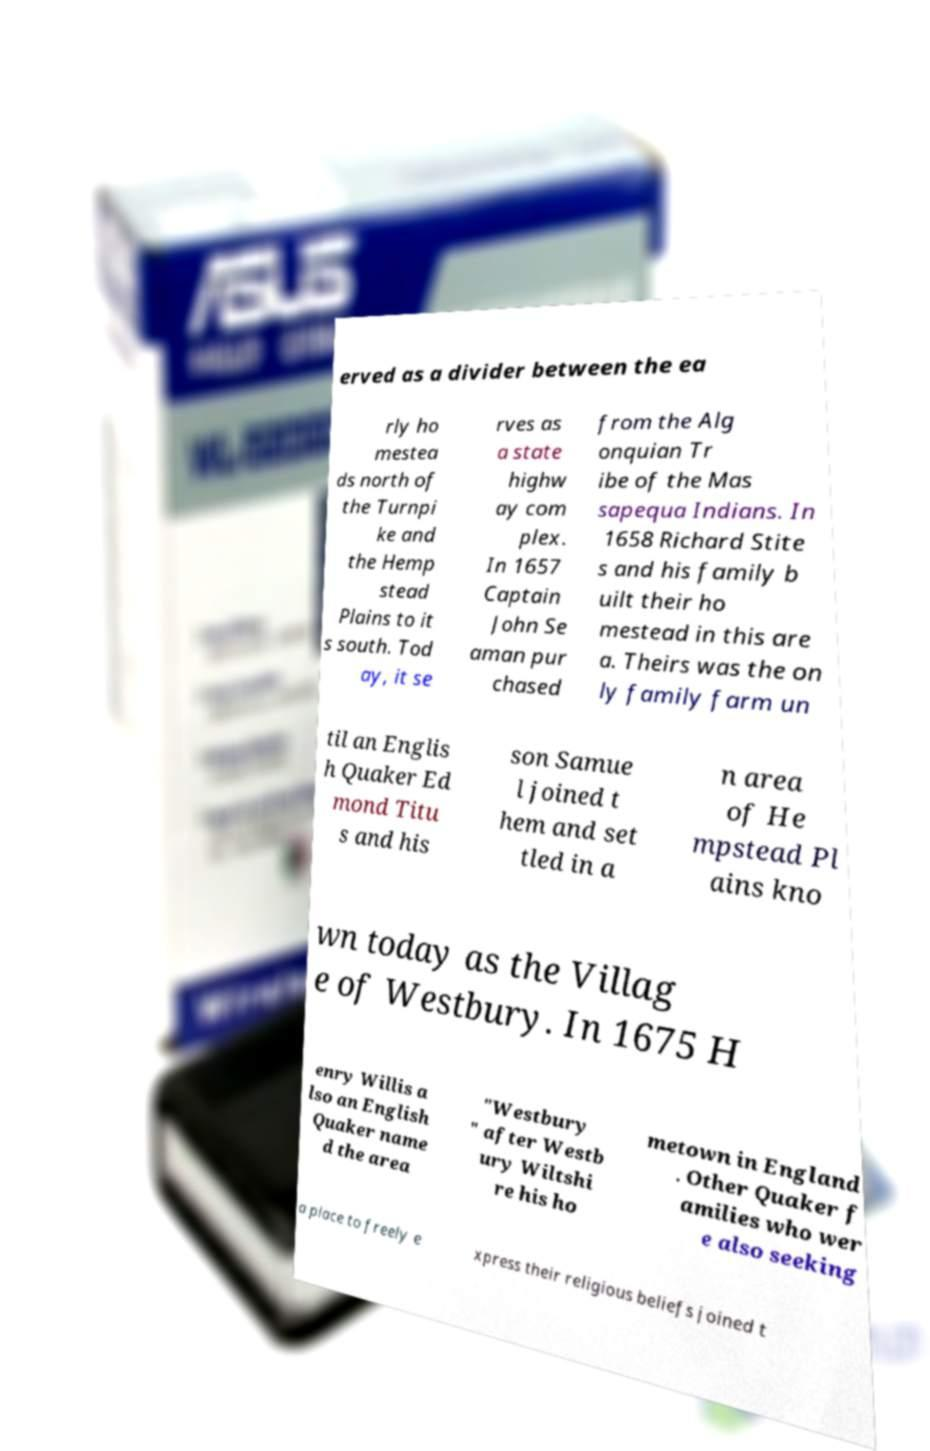I need the written content from this picture converted into text. Can you do that? erved as a divider between the ea rly ho mestea ds north of the Turnpi ke and the Hemp stead Plains to it s south. Tod ay, it se rves as a state highw ay com plex. In 1657 Captain John Se aman pur chased from the Alg onquian Tr ibe of the Mas sapequa Indians. In 1658 Richard Stite s and his family b uilt their ho mestead in this are a. Theirs was the on ly family farm un til an Englis h Quaker Ed mond Titu s and his son Samue l joined t hem and set tled in a n area of He mpstead Pl ains kno wn today as the Villag e of Westbury. In 1675 H enry Willis a lso an English Quaker name d the area "Westbury " after Westb ury Wiltshi re his ho metown in England . Other Quaker f amilies who wer e also seeking a place to freely e xpress their religious beliefs joined t 